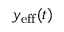Convert formula to latex. <formula><loc_0><loc_0><loc_500><loc_500>y _ { e f f } ( t )</formula> 